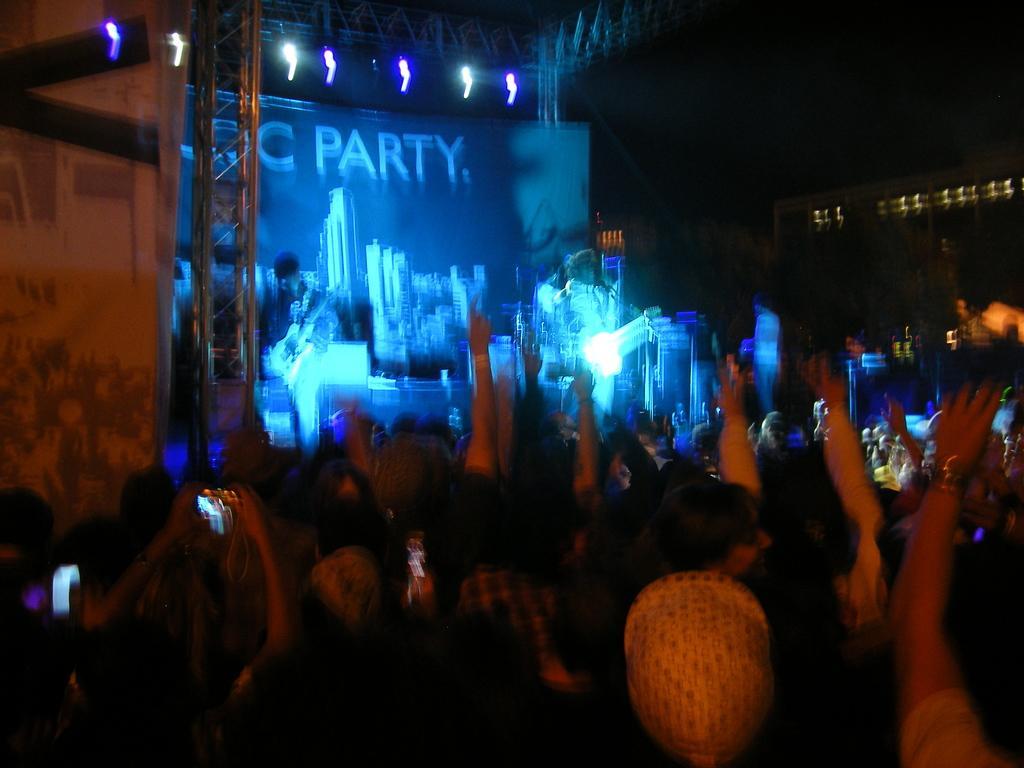Could you give a brief overview of what you see in this image? We can see group of people. Background it is blurry and dark and top of the image we can see focusing lights. 